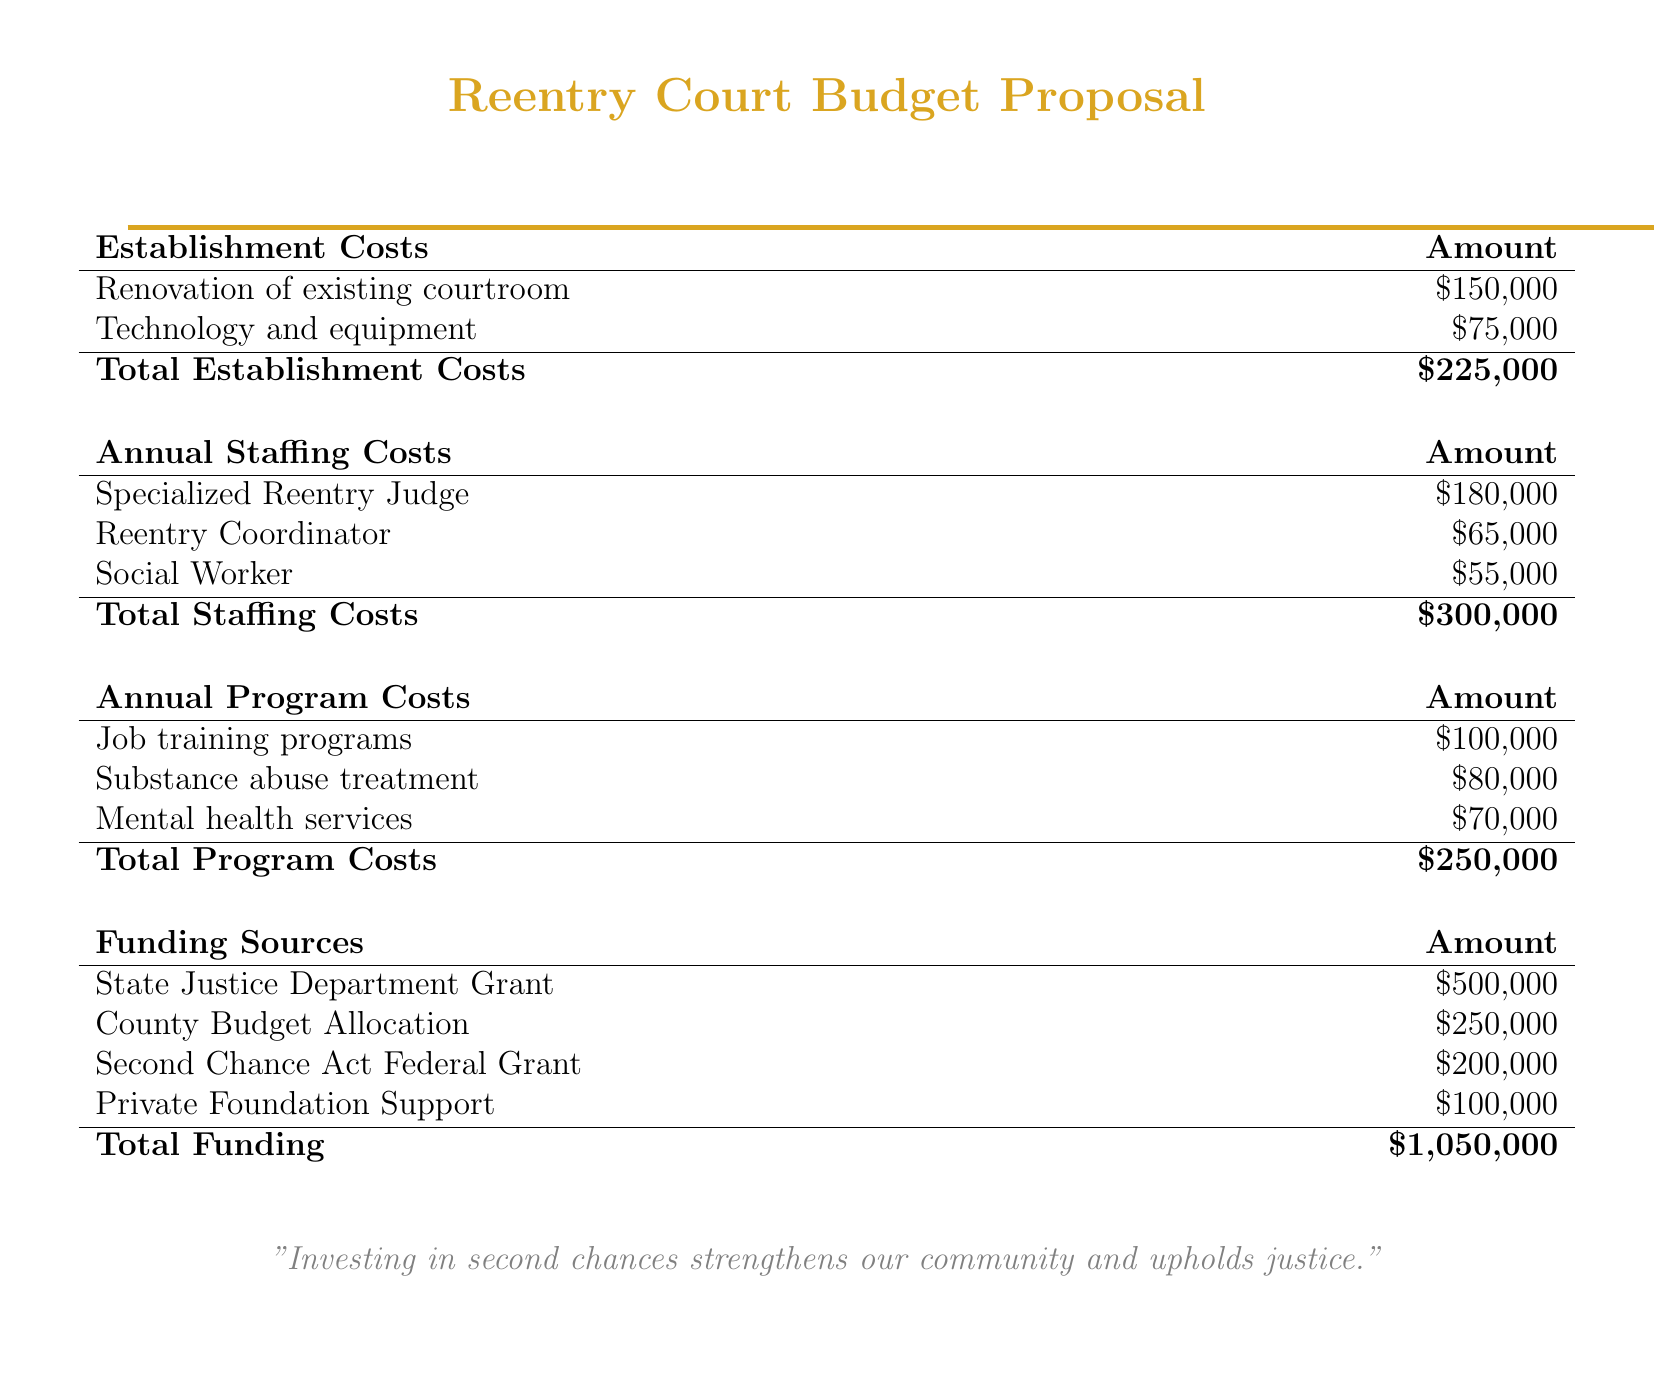What are the total establishment costs? The total establishment costs are provided in the budget as the sum of renovation and technology expenses, which is $150,000 + $75,000.
Answer: $225,000 Who is the specialized reentry judge's salary? The document lists the salary amount dedicated to the specialized reentry judge as part of the annual staffing costs.
Answer: $180,000 What is the annual cost for job training programs? The budget specifies an annual cost for job training programs under the program costs section.
Answer: $100,000 What is the total funding amount? The total funding amounts to the sum of all funding sources listed in the document, totaling $500,000, $250,000, $200,000, and $100,000.
Answer: $1,050,000 Which federal grant is mentioned? The document references a specific federal grant as one of the funding sources, which is named in the funding table.
Answer: Second Chance Act Federal Grant What is the annual cost for mental health services? The budget provides the annual cost for mental health services in the program costs section of the document.
Answer: $70,000 How much funding is allocated from private foundations? The document details the amount of funding support that comes from private foundations in the funding sources.
Answer: $100,000 What is the total for annual program costs? The total for annual program costs is calculated from the sums of job training programs, substance abuse treatment, and mental health services.
Answer: $250,000 